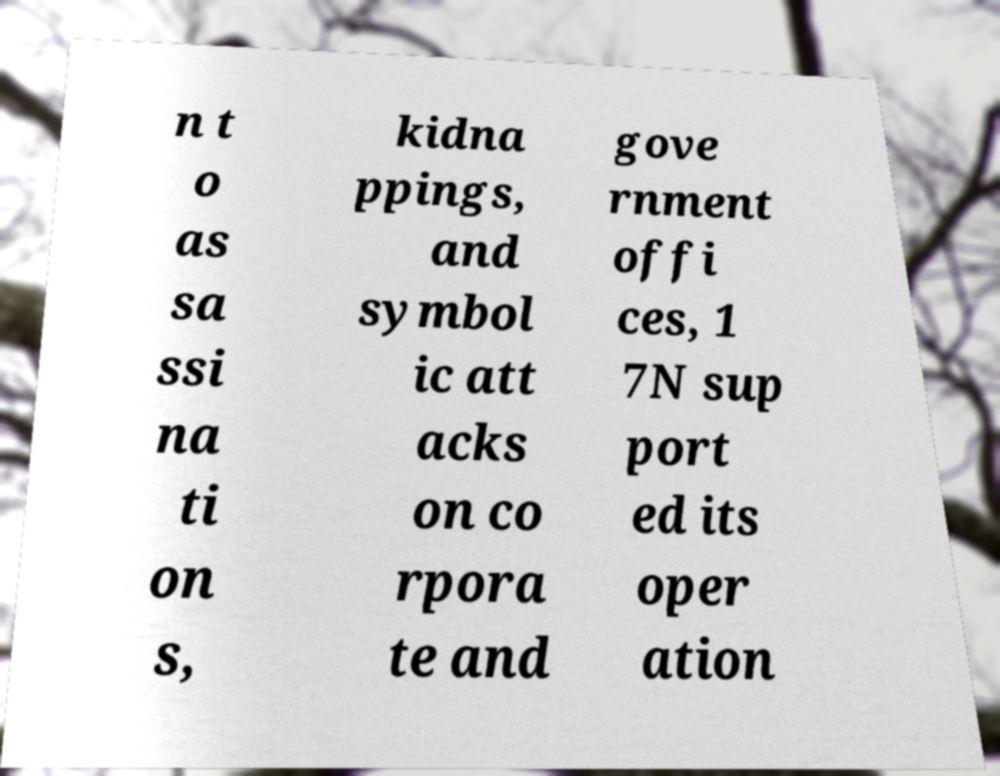Can you accurately transcribe the text from the provided image for me? n t o as sa ssi na ti on s, kidna ppings, and symbol ic att acks on co rpora te and gove rnment offi ces, 1 7N sup port ed its oper ation 